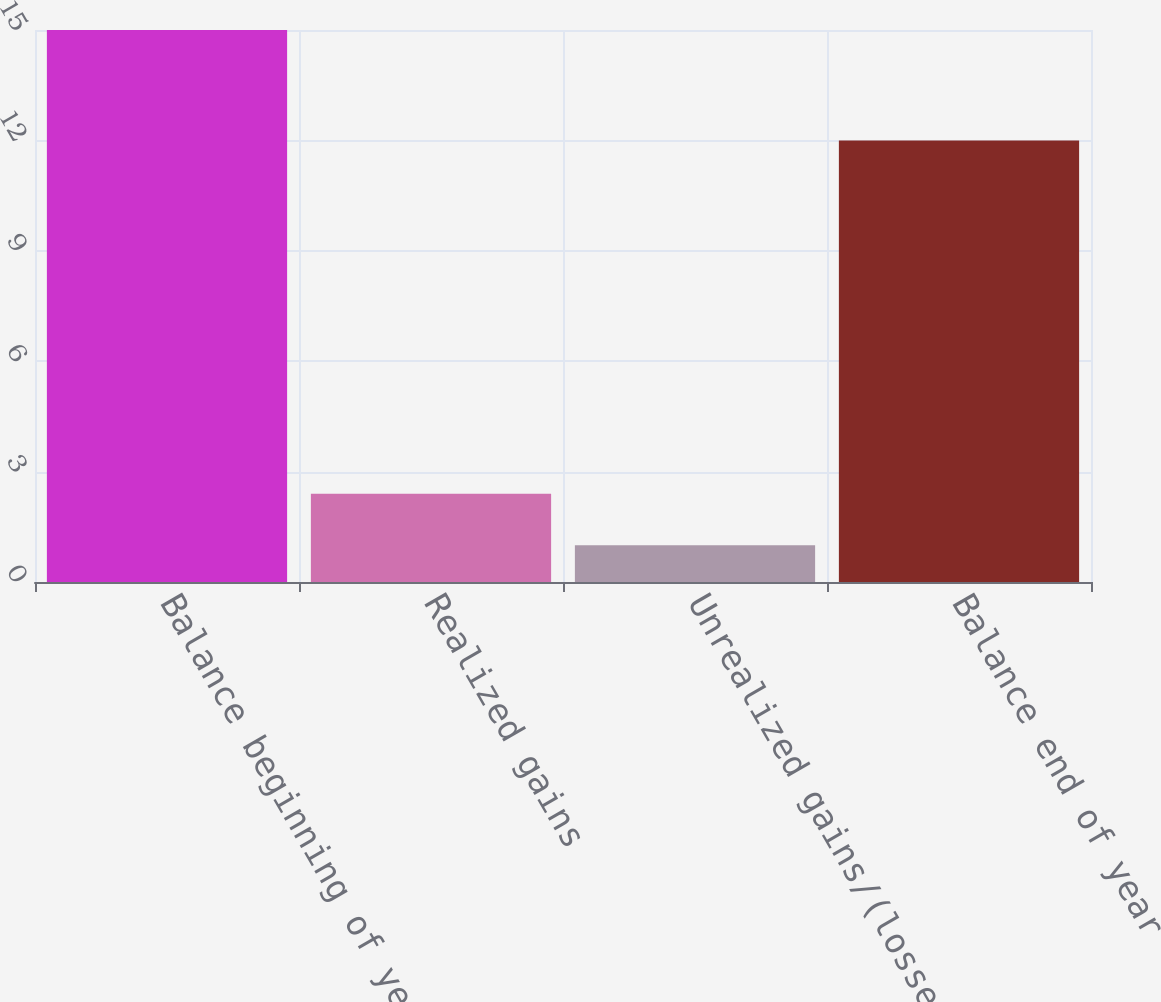Convert chart. <chart><loc_0><loc_0><loc_500><loc_500><bar_chart><fcel>Balance beginning of year<fcel>Realized gains<fcel>Unrealized gains/(losses)<fcel>Balance end of year<nl><fcel>15<fcel>2.4<fcel>1<fcel>12<nl></chart> 